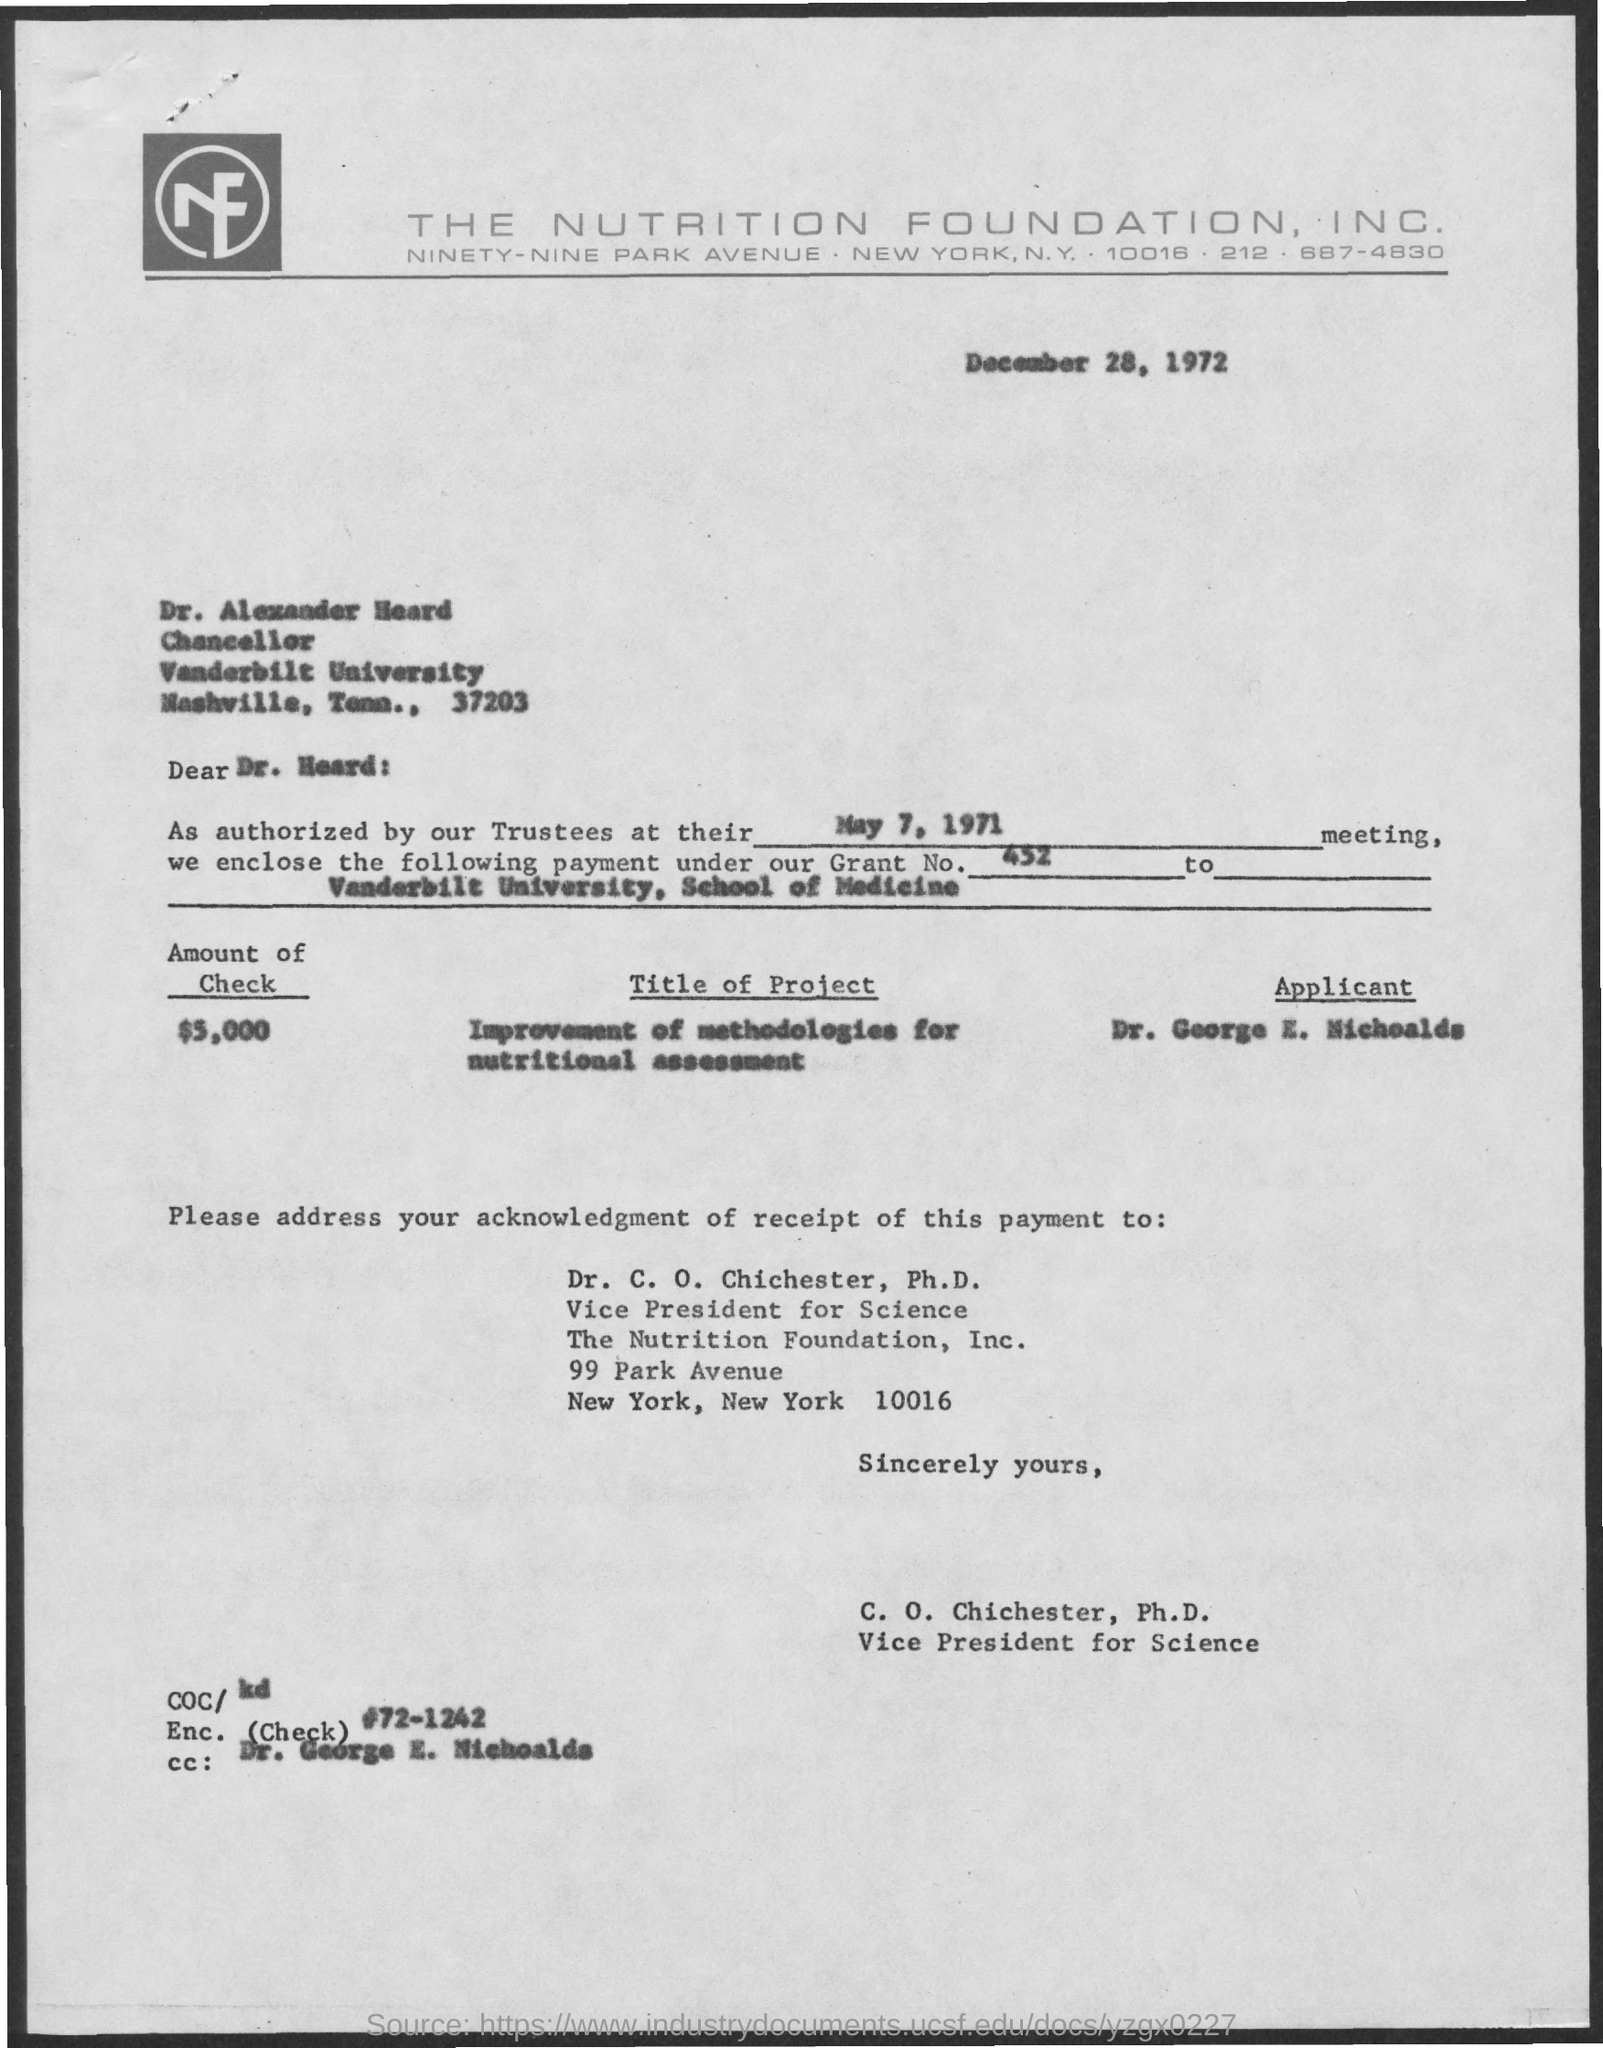What is the grant no ?
Give a very brief answer. 452. What is the name of the university mentioned ?
Make the answer very short. Vanderbilt University, School of Medicine. What is the title of the project
Offer a very short reply. Improvement of methodologies for Nutritional assessment. When is the meeting held
Provide a short and direct response. May 7, 1971. How much is the amount of check
Make the answer very short. $ 5,000. What is the applicant name mentioned ?
Your answer should be compact. Dr. George E. Nichoalds. Who is mentioned in the cc:
Provide a short and direct response. Dr. George E. Nichoalds. 